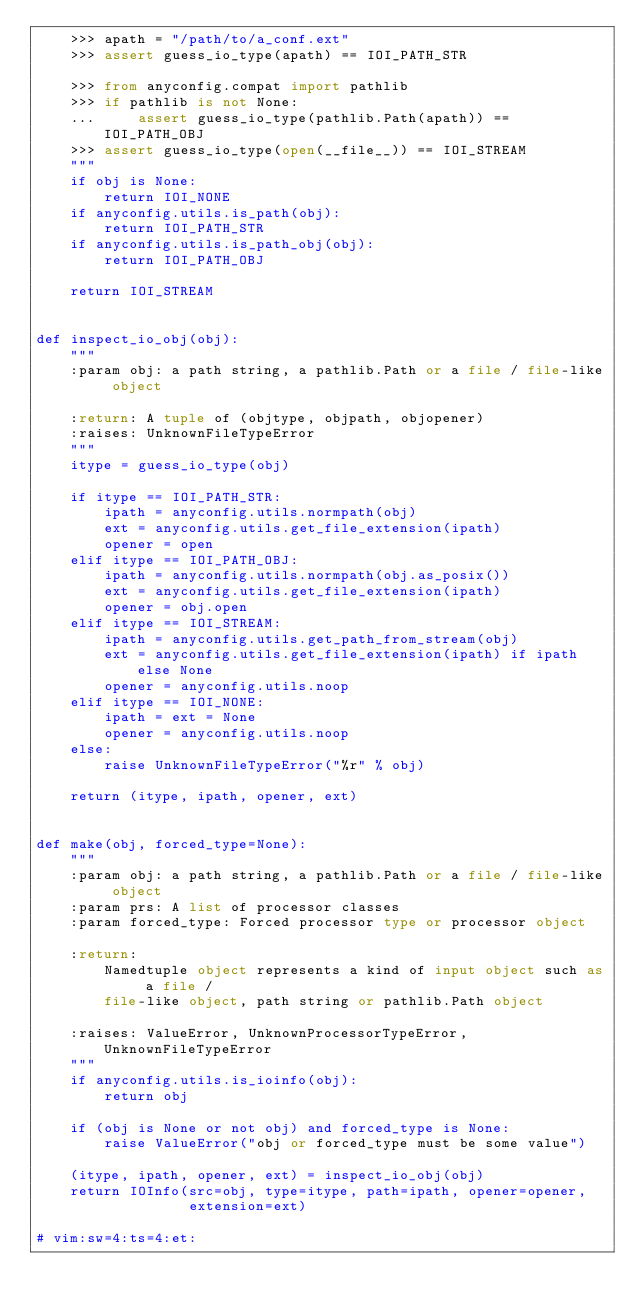<code> <loc_0><loc_0><loc_500><loc_500><_Python_>    >>> apath = "/path/to/a_conf.ext"
    >>> assert guess_io_type(apath) == IOI_PATH_STR

    >>> from anyconfig.compat import pathlib
    >>> if pathlib is not None:
    ...     assert guess_io_type(pathlib.Path(apath)) == IOI_PATH_OBJ
    >>> assert guess_io_type(open(__file__)) == IOI_STREAM
    """
    if obj is None:
        return IOI_NONE
    if anyconfig.utils.is_path(obj):
        return IOI_PATH_STR
    if anyconfig.utils.is_path_obj(obj):
        return IOI_PATH_OBJ

    return IOI_STREAM


def inspect_io_obj(obj):
    """
    :param obj: a path string, a pathlib.Path or a file / file-like object

    :return: A tuple of (objtype, objpath, objopener)
    :raises: UnknownFileTypeError
    """
    itype = guess_io_type(obj)

    if itype == IOI_PATH_STR:
        ipath = anyconfig.utils.normpath(obj)
        ext = anyconfig.utils.get_file_extension(ipath)
        opener = open
    elif itype == IOI_PATH_OBJ:
        ipath = anyconfig.utils.normpath(obj.as_posix())
        ext = anyconfig.utils.get_file_extension(ipath)
        opener = obj.open
    elif itype == IOI_STREAM:
        ipath = anyconfig.utils.get_path_from_stream(obj)
        ext = anyconfig.utils.get_file_extension(ipath) if ipath else None
        opener = anyconfig.utils.noop
    elif itype == IOI_NONE:
        ipath = ext = None
        opener = anyconfig.utils.noop
    else:
        raise UnknownFileTypeError("%r" % obj)

    return (itype, ipath, opener, ext)


def make(obj, forced_type=None):
    """
    :param obj: a path string, a pathlib.Path or a file / file-like object
    :param prs: A list of processor classes
    :param forced_type: Forced processor type or processor object

    :return:
        Namedtuple object represents a kind of input object such as a file /
        file-like object, path string or pathlib.Path object

    :raises: ValueError, UnknownProcessorTypeError, UnknownFileTypeError
    """
    if anyconfig.utils.is_ioinfo(obj):
        return obj

    if (obj is None or not obj) and forced_type is None:
        raise ValueError("obj or forced_type must be some value")

    (itype, ipath, opener, ext) = inspect_io_obj(obj)
    return IOInfo(src=obj, type=itype, path=ipath, opener=opener,
                  extension=ext)

# vim:sw=4:ts=4:et:
</code> 